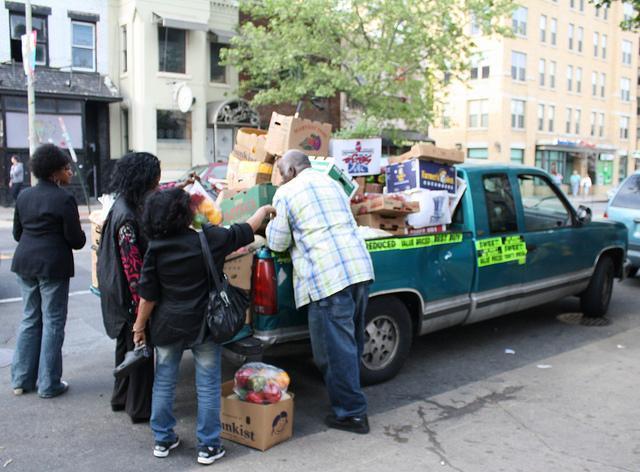Why is there green tape on the pickup?
Choose the correct response, then elucidate: 'Answer: answer
Rationale: rationale.'
Options: Repairs, vandalism, advertising, decorative. Answer: advertising.
Rationale: The bed of the truck is full of boxes that appear to be from a vendor.  there are people going through boxes. 